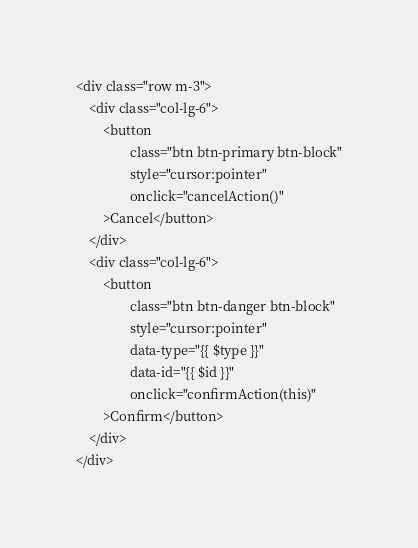<code> <loc_0><loc_0><loc_500><loc_500><_PHP_><div class="row m-3">
    <div class="col-lg-6">
        <button
                class="btn btn-primary btn-block"
                style="cursor:pointer"
                onclick="cancelAction()"
        >Cancel</button>
    </div>
    <div class="col-lg-6">
        <button
                class="btn btn-danger btn-block"
                style="cursor:pointer"
                data-type="{{ $type }}"
                data-id="{{ $id }}"
                onclick="confirmAction(this)"
        >Confirm</button>
    </div>
</div></code> 